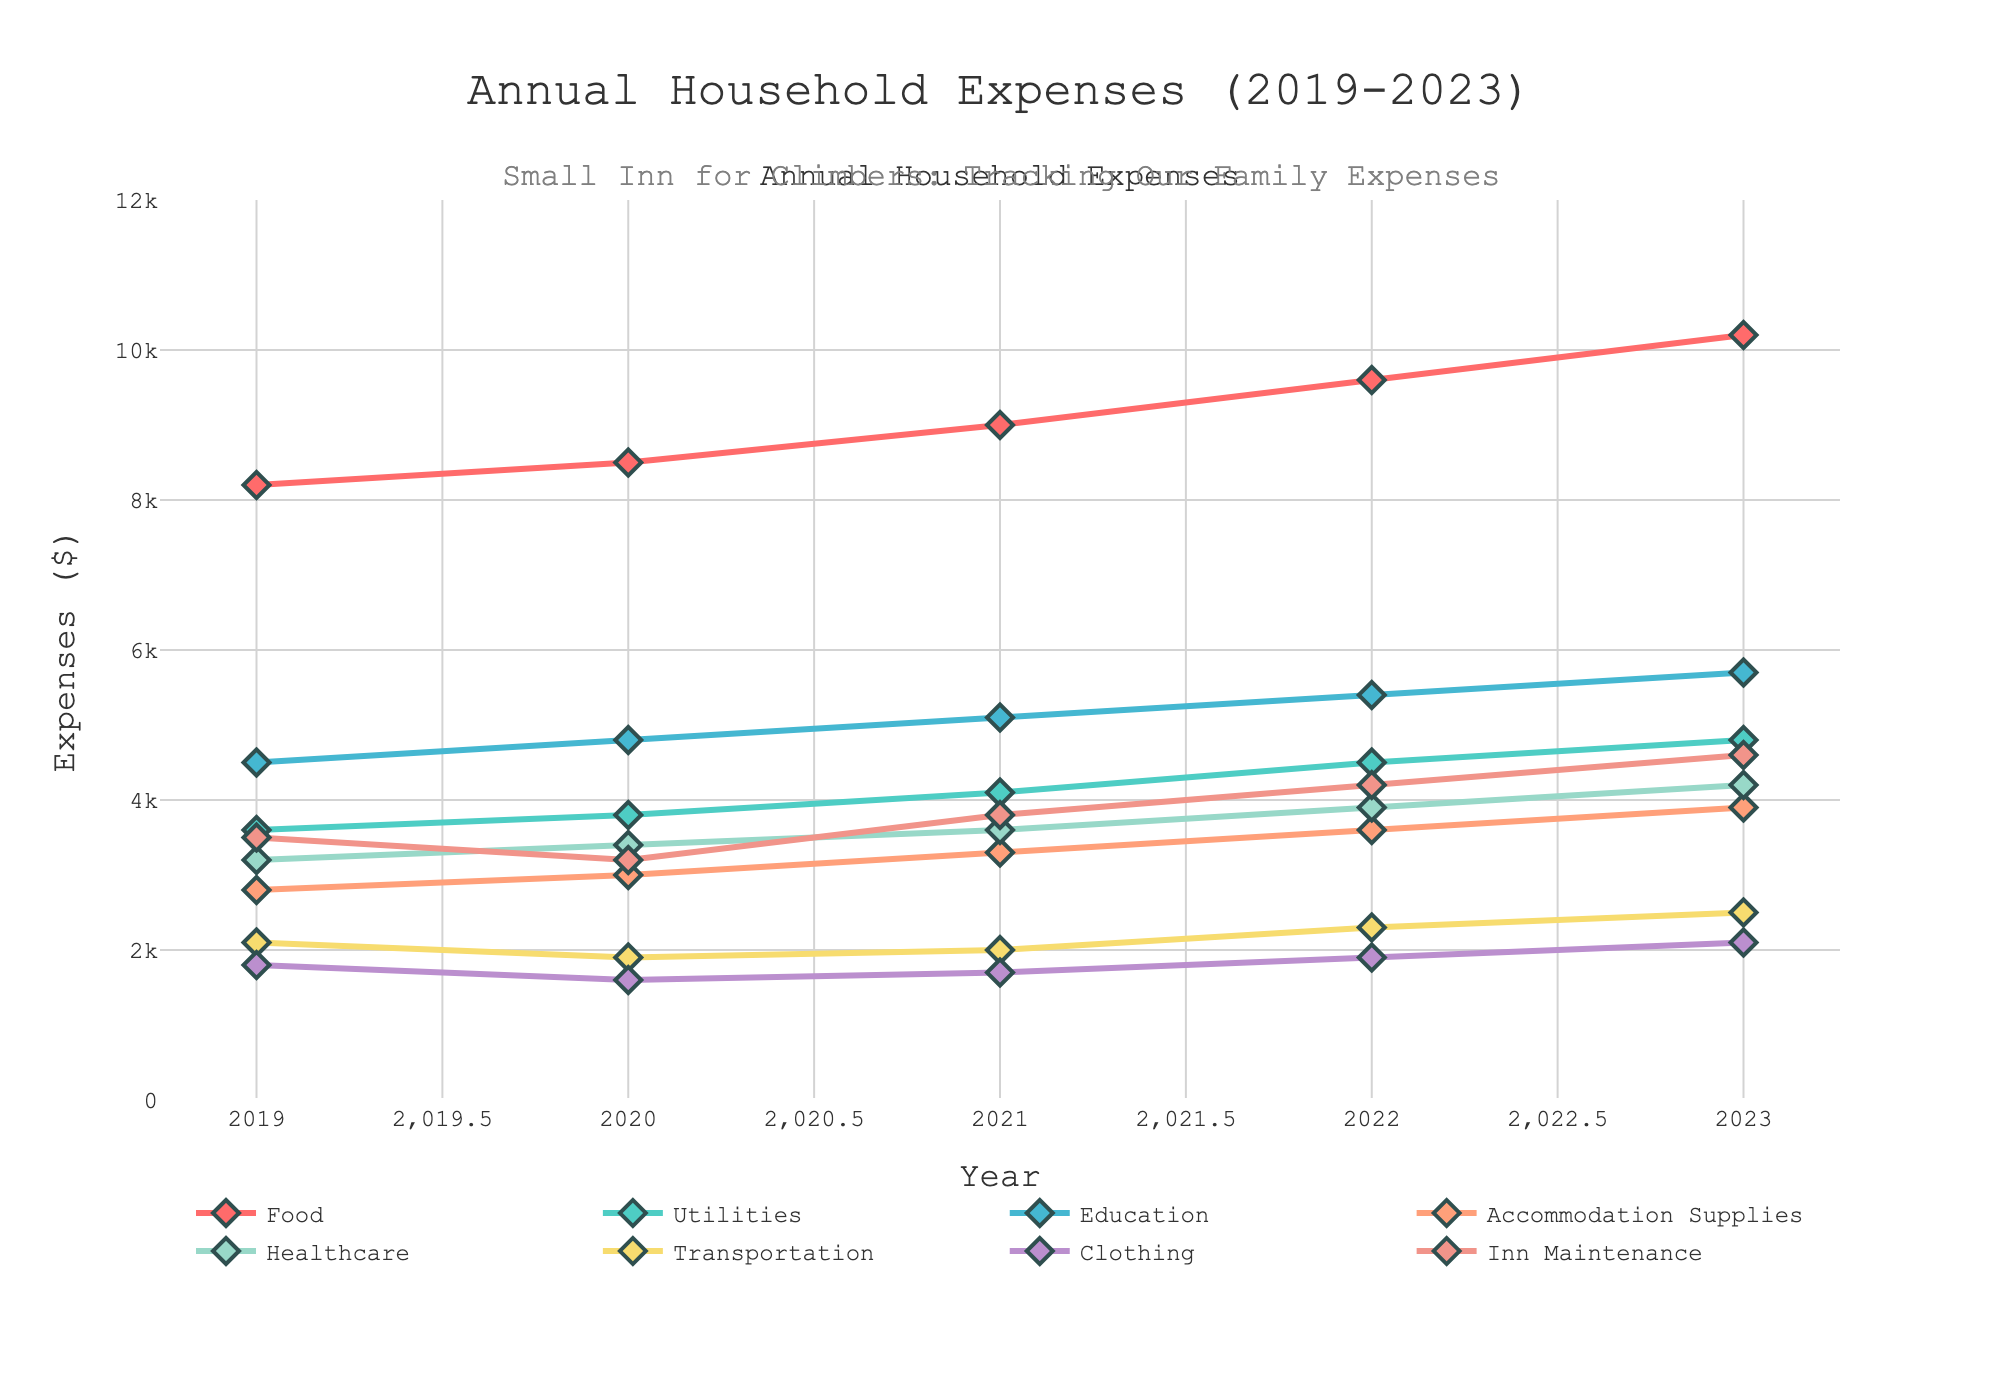What's the total amount spent on Food from 2019 to 2023? To find the total amount spent on Food from 2019 to 2023, we add the annual amounts: 8200 (2019) + 8500 (2020) + 9000 (2021) + 9600 (2022) + 10200 (2023) = 45600.
Answer: 45600 Which year had the highest expenses on Healthcare? Examine the Healthcare expenses year by year: 3200 (2019), 3400 (2020), 3600 (2021), 3900 (2022), 4200 (2023). The highest expense is in 2023.
Answer: 2023 Which expense increased most consistently over the years? To determine this, we need to analyze the trend for each expense category over the years. Food and Education both have consistent increases annually: Food (8200→8500→9000→9600→10200) and Education (4500→4800→5100→5400→5700). Food has the largest consistent increase.
Answer: Food How much more was spent on Inn Maintenance in 2023 compared to 2019? Subtract the 2019 value from the 2023 value for Inn Maintenance: 4600 (2023) - 3500 (2019) = 1100.
Answer: 1100 What's the average annual expense on Utilities from 2019 to 2023? Calculate the average by summing up the annual Utilities expenses and dividing by the number of years: (3600 + 3800 + 4100 + 4500 + 4800) / 5 = 4160.
Answer: 4160 In which year was the expenditure on Transportation the lowest? By examining the data, we find the annual expenses on Transportation: 2100 (2019), 1900 (2020), 2000 (2021), 2300 (2022), 2500 (2023). The lowest amount is 1900 in 2020.
Answer: 2020 What is the difference between the highest and lowest annual Clothing expenses within the given years? Identify the highest and lowest Clothing expenses: highest is 2100 (2023) and lowest is 1600 (2020). Difference: 2100 - 1600 = 500.
Answer: 500 Compare the Inn Maintenance expenses in 2021 and 2023. How much more or less was spent in 2023? Note the Inn Maintenance expenses: 3800 (2021) and 4600 (2023). Difference: 4600 - 3800 = 800; therefore, 800 more was spent in 2023.
Answer: 800 Which category had the least spending in 2021? Compare the expenses for each category in 2021: Food (9000), Utilities (4100), Education (5100), Accommodation Supplies (3300), Healthcare (3600), Transportation (2000), Clothing (1700), Inn Maintenance (3800). The least expenditure is on Transportation (2000).
Answer: Transportation What was the expenditure on Accommodation Supplies in 2021 and how does it compare to 2022? The expenditure for Accommodation Supplies in 2021 is 3300 and in 2022 is 3600. The difference is 3600 - 3300 = 300 more spent in 2022.
Answer: 300 more in 2022 